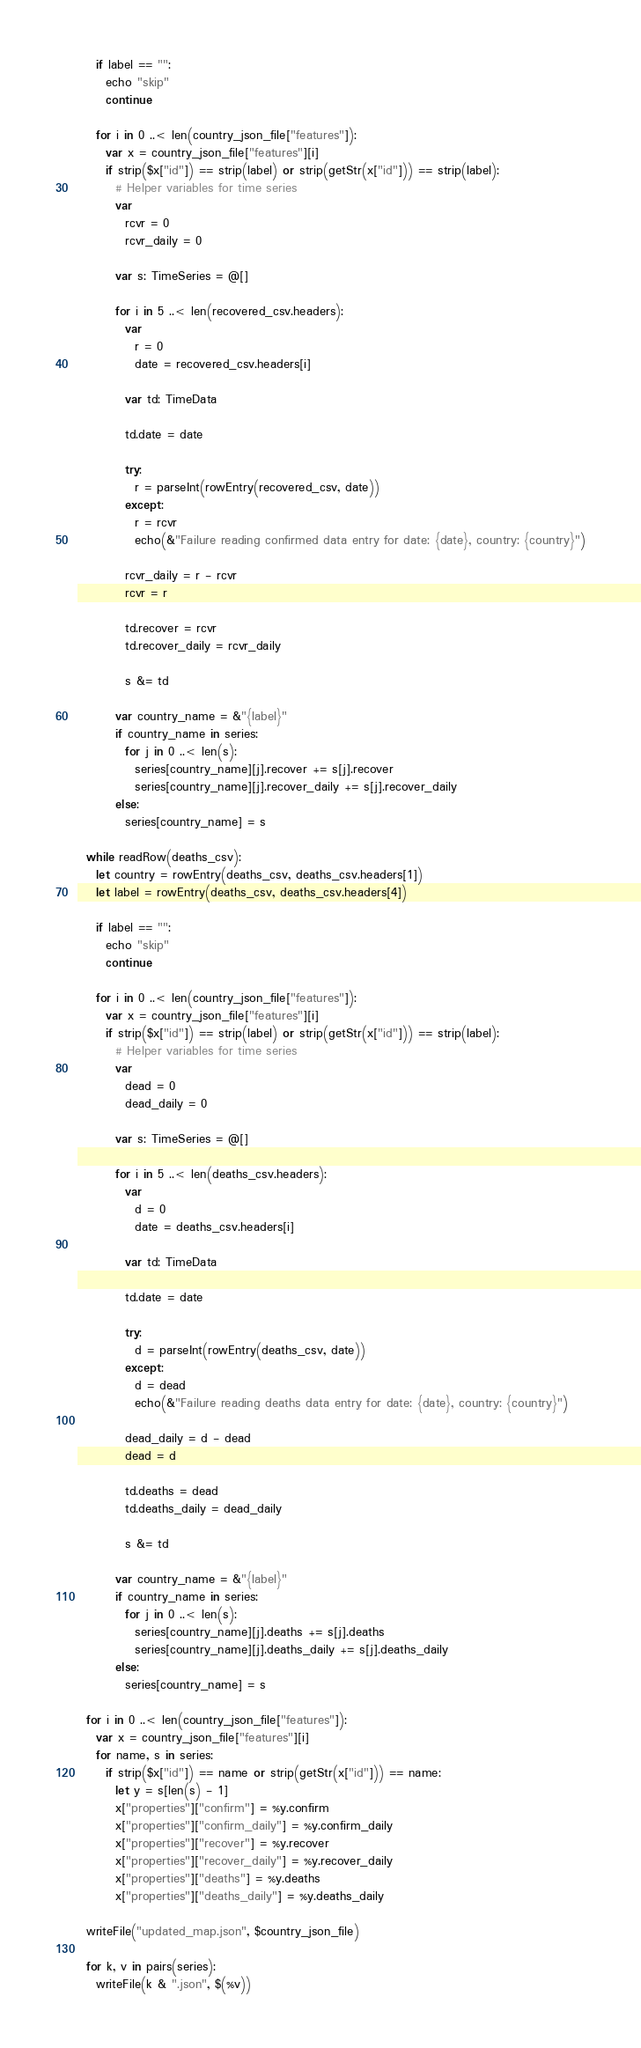Convert code to text. <code><loc_0><loc_0><loc_500><loc_500><_Nim_>    if label == "":
      echo "skip"
      continue

    for i in 0 ..< len(country_json_file["features"]):
      var x = country_json_file["features"][i]
      if strip($x["id"]) == strip(label) or strip(getStr(x["id"])) == strip(label):
        # Helper variables for time series
        var
          rcvr = 0
          rcvr_daily = 0

        var s: TimeSeries = @[]

        for i in 5 ..< len(recovered_csv.headers):
          var
            r = 0
            date = recovered_csv.headers[i]

          var td: TimeData

          td.date = date

          try:
            r = parseInt(rowEntry(recovered_csv, date))
          except:
            r = rcvr
            echo(&"Failure reading confirmed data entry for date: {date}, country: {country}")

          rcvr_daily = r - rcvr
          rcvr = r

          td.recover = rcvr
          td.recover_daily = rcvr_daily

          s &= td

        var country_name = &"{label}"
        if country_name in series:
          for j in 0 ..< len(s):
            series[country_name][j].recover += s[j].recover
            series[country_name][j].recover_daily += s[j].recover_daily
        else:
          series[country_name] = s

  while readRow(deaths_csv):
    let country = rowEntry(deaths_csv, deaths_csv.headers[1])
    let label = rowEntry(deaths_csv, deaths_csv.headers[4])

    if label == "":
      echo "skip"
      continue

    for i in 0 ..< len(country_json_file["features"]):
      var x = country_json_file["features"][i]
      if strip($x["id"]) == strip(label) or strip(getStr(x["id"])) == strip(label):
        # Helper variables for time series
        var
          dead = 0
          dead_daily = 0

        var s: TimeSeries = @[]

        for i in 5 ..< len(deaths_csv.headers):
          var
            d = 0
            date = deaths_csv.headers[i]

          var td: TimeData

          td.date = date

          try:
            d = parseInt(rowEntry(deaths_csv, date))
          except:
            d = dead
            echo(&"Failure reading deaths data entry for date: {date}, country: {country}")

          dead_daily = d - dead
          dead = d

          td.deaths = dead
          td.deaths_daily = dead_daily

          s &= td

        var country_name = &"{label}"
        if country_name in series:
          for j in 0 ..< len(s):
            series[country_name][j].deaths += s[j].deaths
            series[country_name][j].deaths_daily += s[j].deaths_daily
        else:
          series[country_name] = s

  for i in 0 ..< len(country_json_file["features"]):
    var x = country_json_file["features"][i]
    for name, s in series:
      if strip($x["id"]) == name or strip(getStr(x["id"])) == name:
        let y = s[len(s) - 1]
        x["properties"]["confirm"] = %y.confirm
        x["properties"]["confirm_daily"] = %y.confirm_daily
        x["properties"]["recover"] = %y.recover
        x["properties"]["recover_daily"] = %y.recover_daily
        x["properties"]["deaths"] = %y.deaths
        x["properties"]["deaths_daily"] = %y.deaths_daily

  writeFile("updated_map.json", $country_json_file)

  for k, v in pairs(series):
    writeFile(k & ".json", $(%v))
</code> 